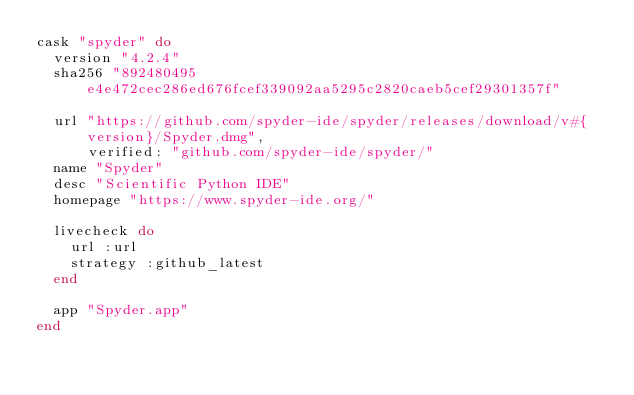Convert code to text. <code><loc_0><loc_0><loc_500><loc_500><_Ruby_>cask "spyder" do
  version "4.2.4"
  sha256 "892480495e4e472cec286ed676fcef339092aa5295c2820caeb5cef29301357f"

  url "https://github.com/spyder-ide/spyder/releases/download/v#{version}/Spyder.dmg",
      verified: "github.com/spyder-ide/spyder/"
  name "Spyder"
  desc "Scientific Python IDE"
  homepage "https://www.spyder-ide.org/"

  livecheck do
    url :url
    strategy :github_latest
  end

  app "Spyder.app"
end
</code> 